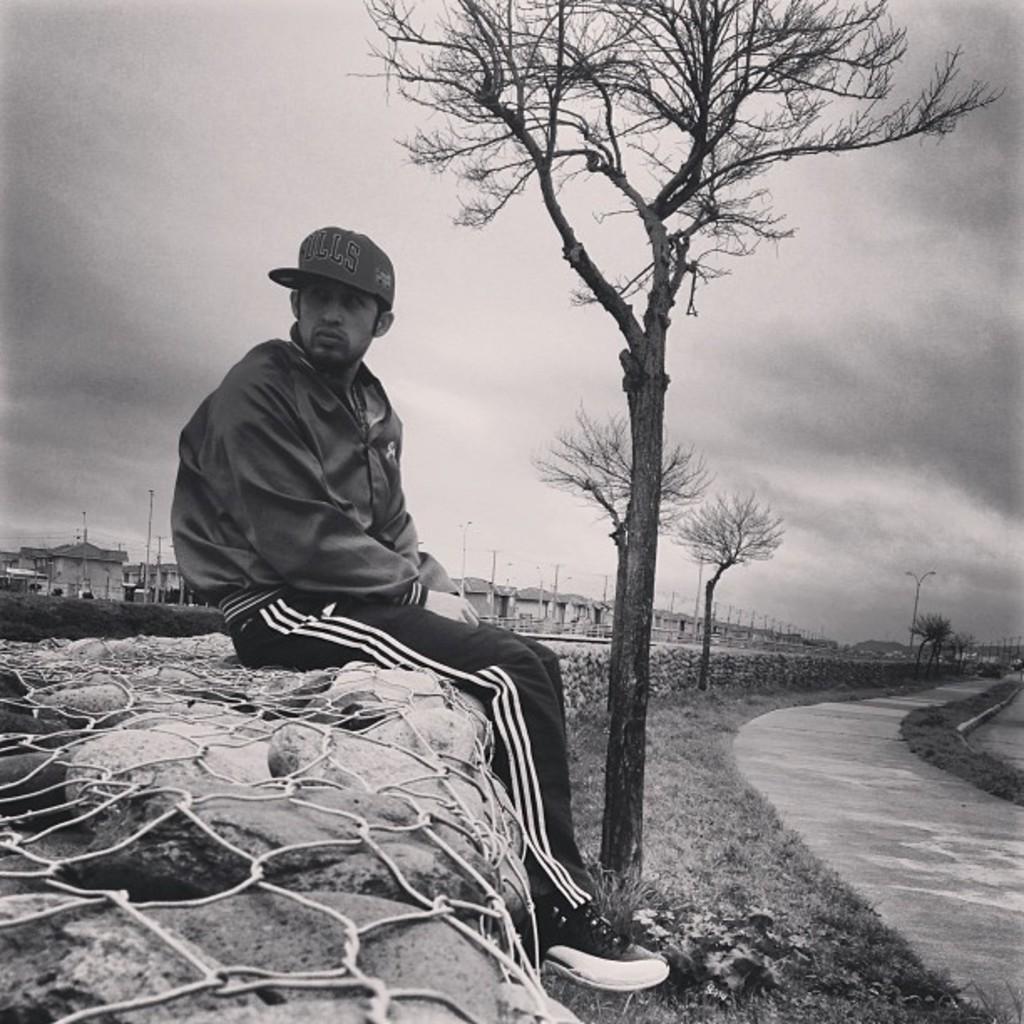Please provide a concise description of this image. This is a black and white picture of a man in jersey,tracks,cap and shoe sitting on a stone wall with trees in front of him on the grassland followed by a path and in the back there are buildings and above its sky with clouds. 